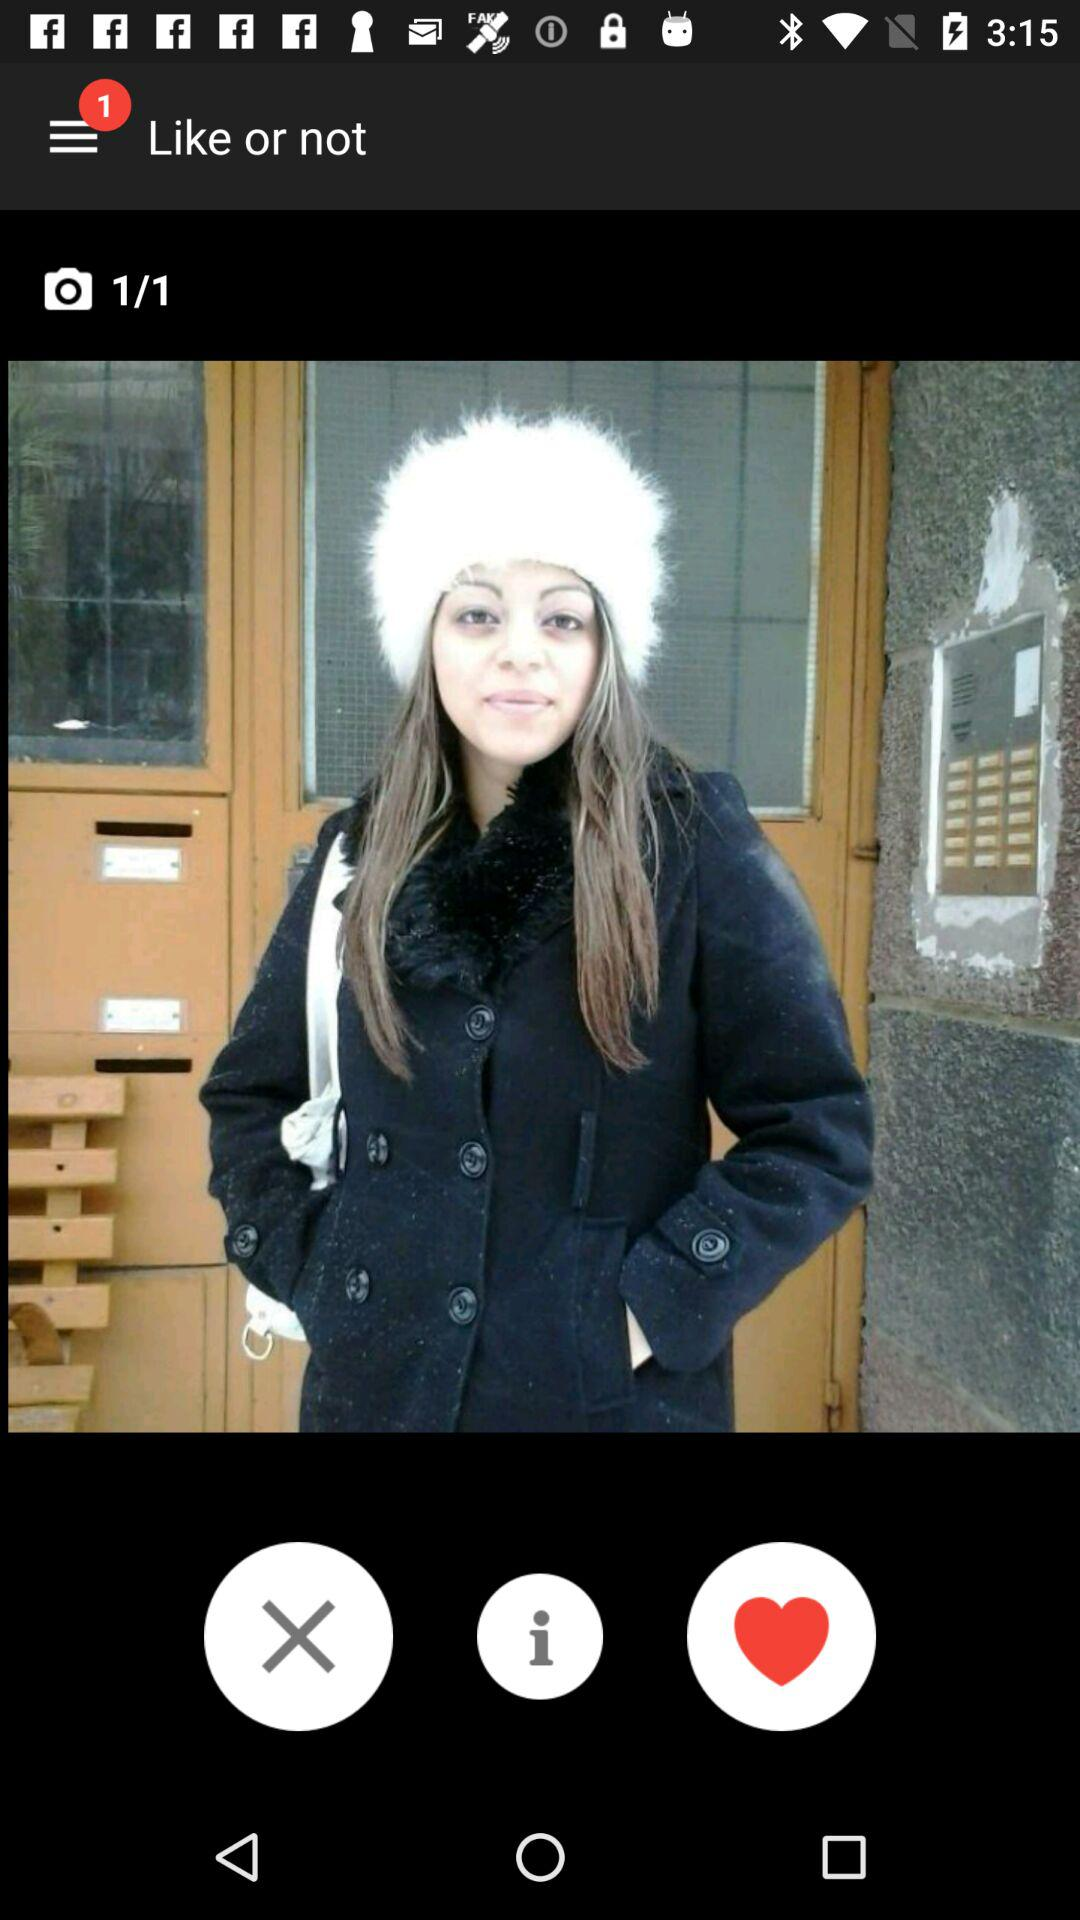How many notifications are there? There is 1 notification. 